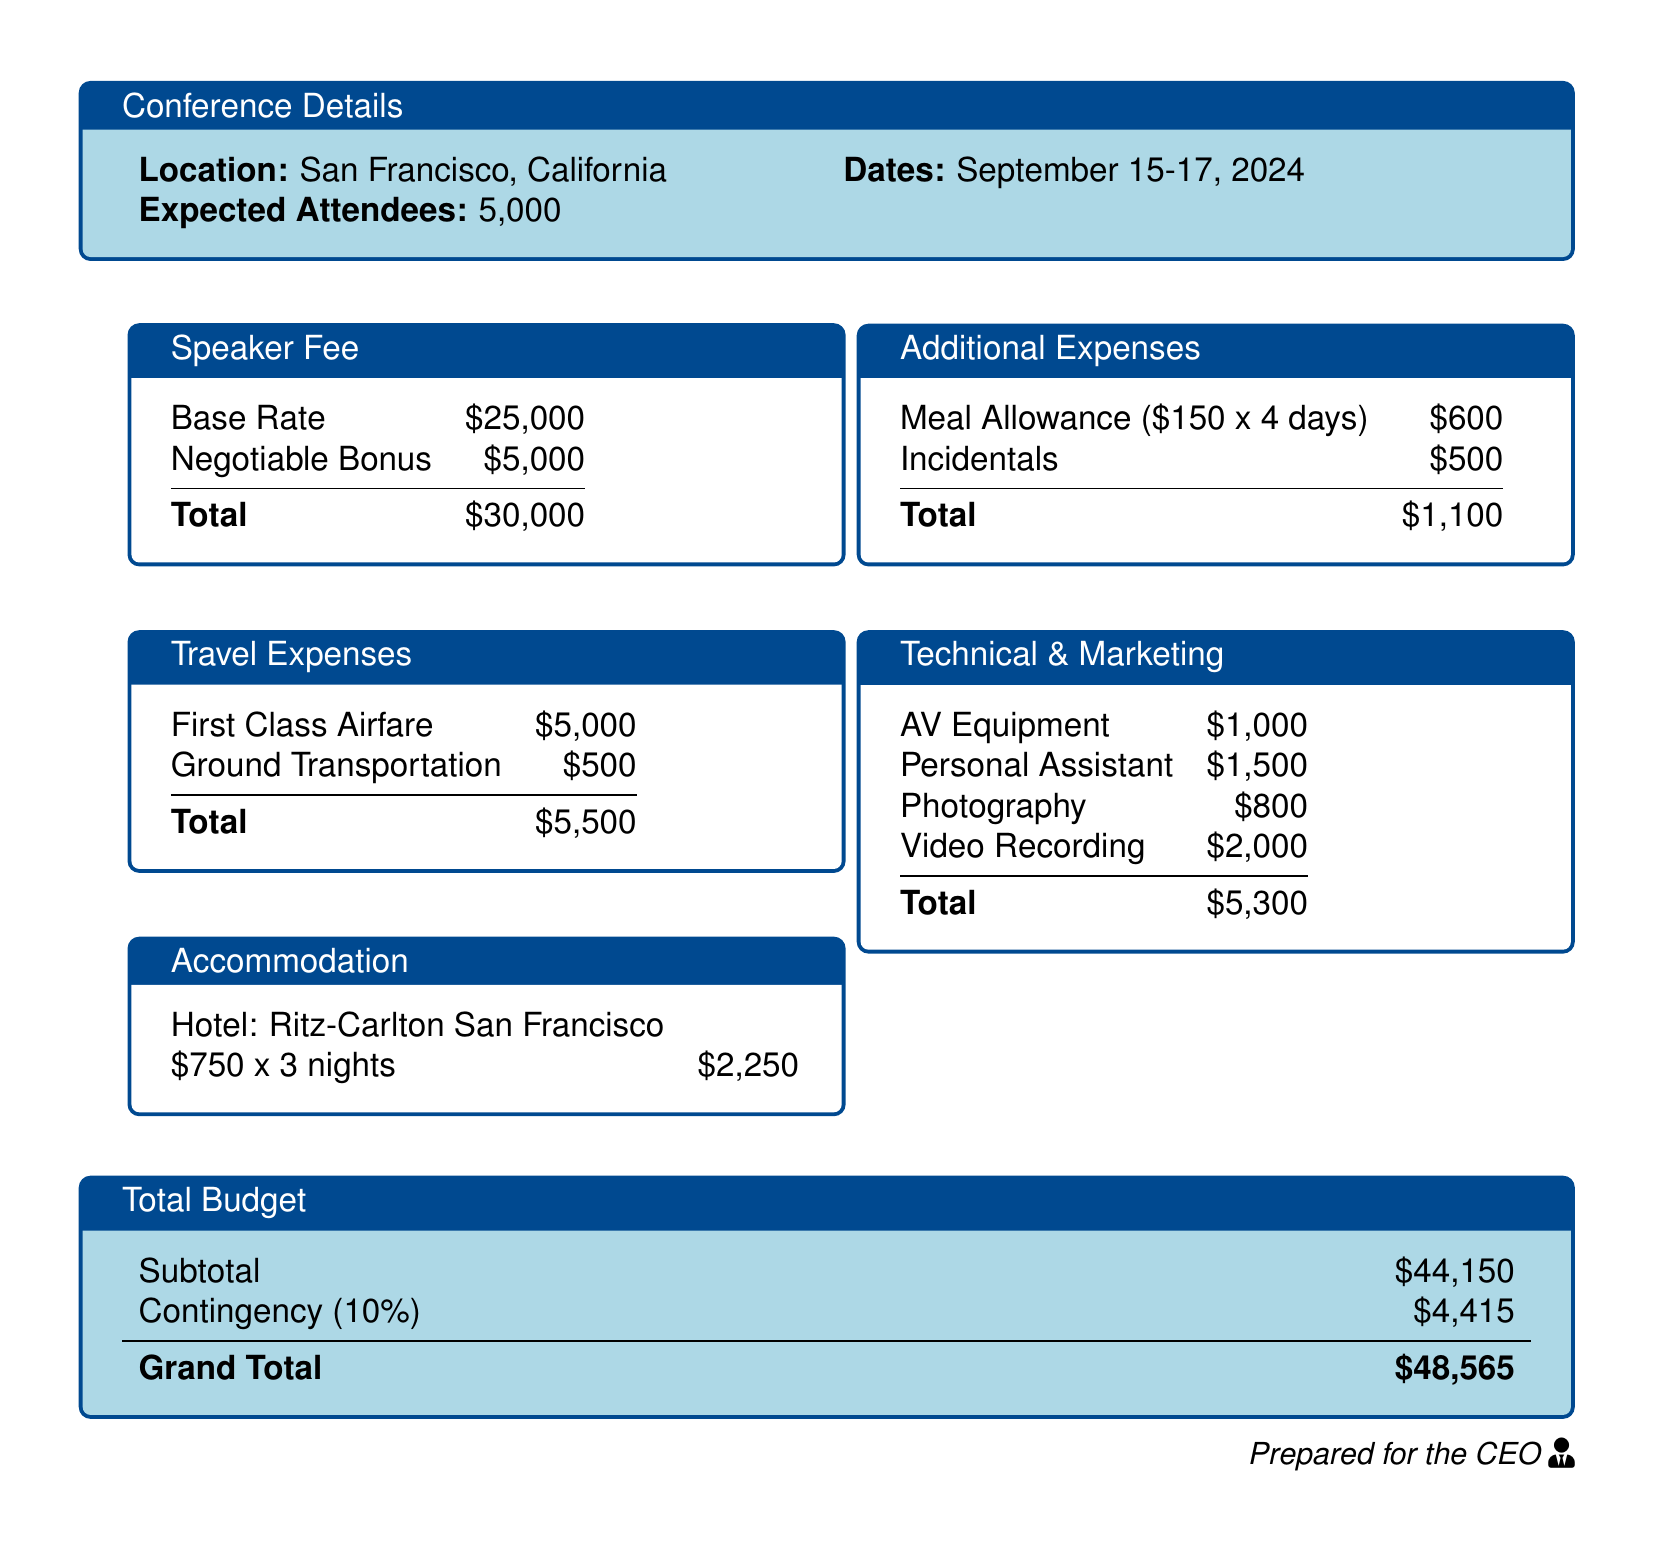What is the base rate for the keynote speaker? The base rate for the keynote speaker is specified in the document.
Answer: $25,000 How much is allocated for first-class airfare? The document lists the travel expenses, including airfare.
Answer: $5,000 What is the hotel rate per night? The accommodation section provides the hotel rate for each night.
Answer: $750 What is the total amount for technical and marketing expenses? The total for technical and marketing expenses is calculated within that section.
Answer: $5,300 What is the total budget before the contingency? The subtotal before contingency is outlined in the total budget section.
Answer: $44,150 What percentage is allocated for the contingency? The document specifies a percentage for the contingency in the total budget.
Answer: 10% What is the total budget, including contingency? The grand total incorporates the subtotal and the contingency amount.
Answer: $48,565 How many nights will the keynote speaker stay at the hotel? The accommodation details indicate the number of nights for the hotel stay.
Answer: 3 nights How much is the meal allowance for the entire duration of the conference? The meal allowance is detailed for the duration of the conference.
Answer: $600 